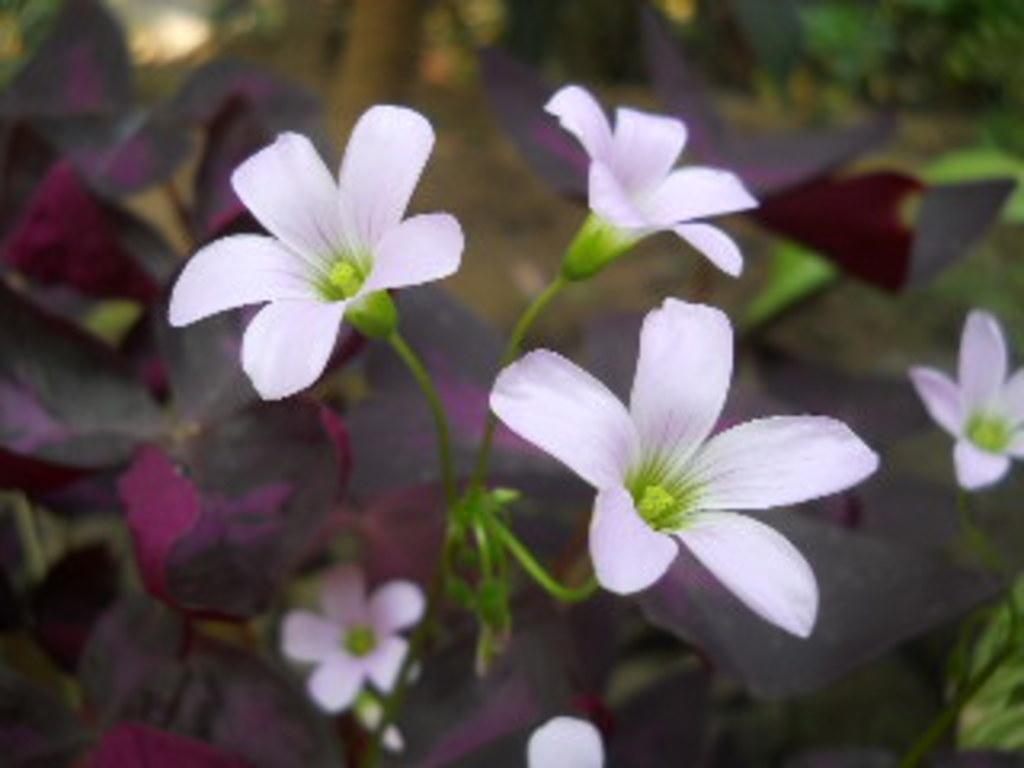Describe this image in one or two sentences. In this picture, we see a plant which has flowers and these flowers are in white color. This plant is in dark purple color. In the right top, we see the trees. This picture is blurred in the background. 